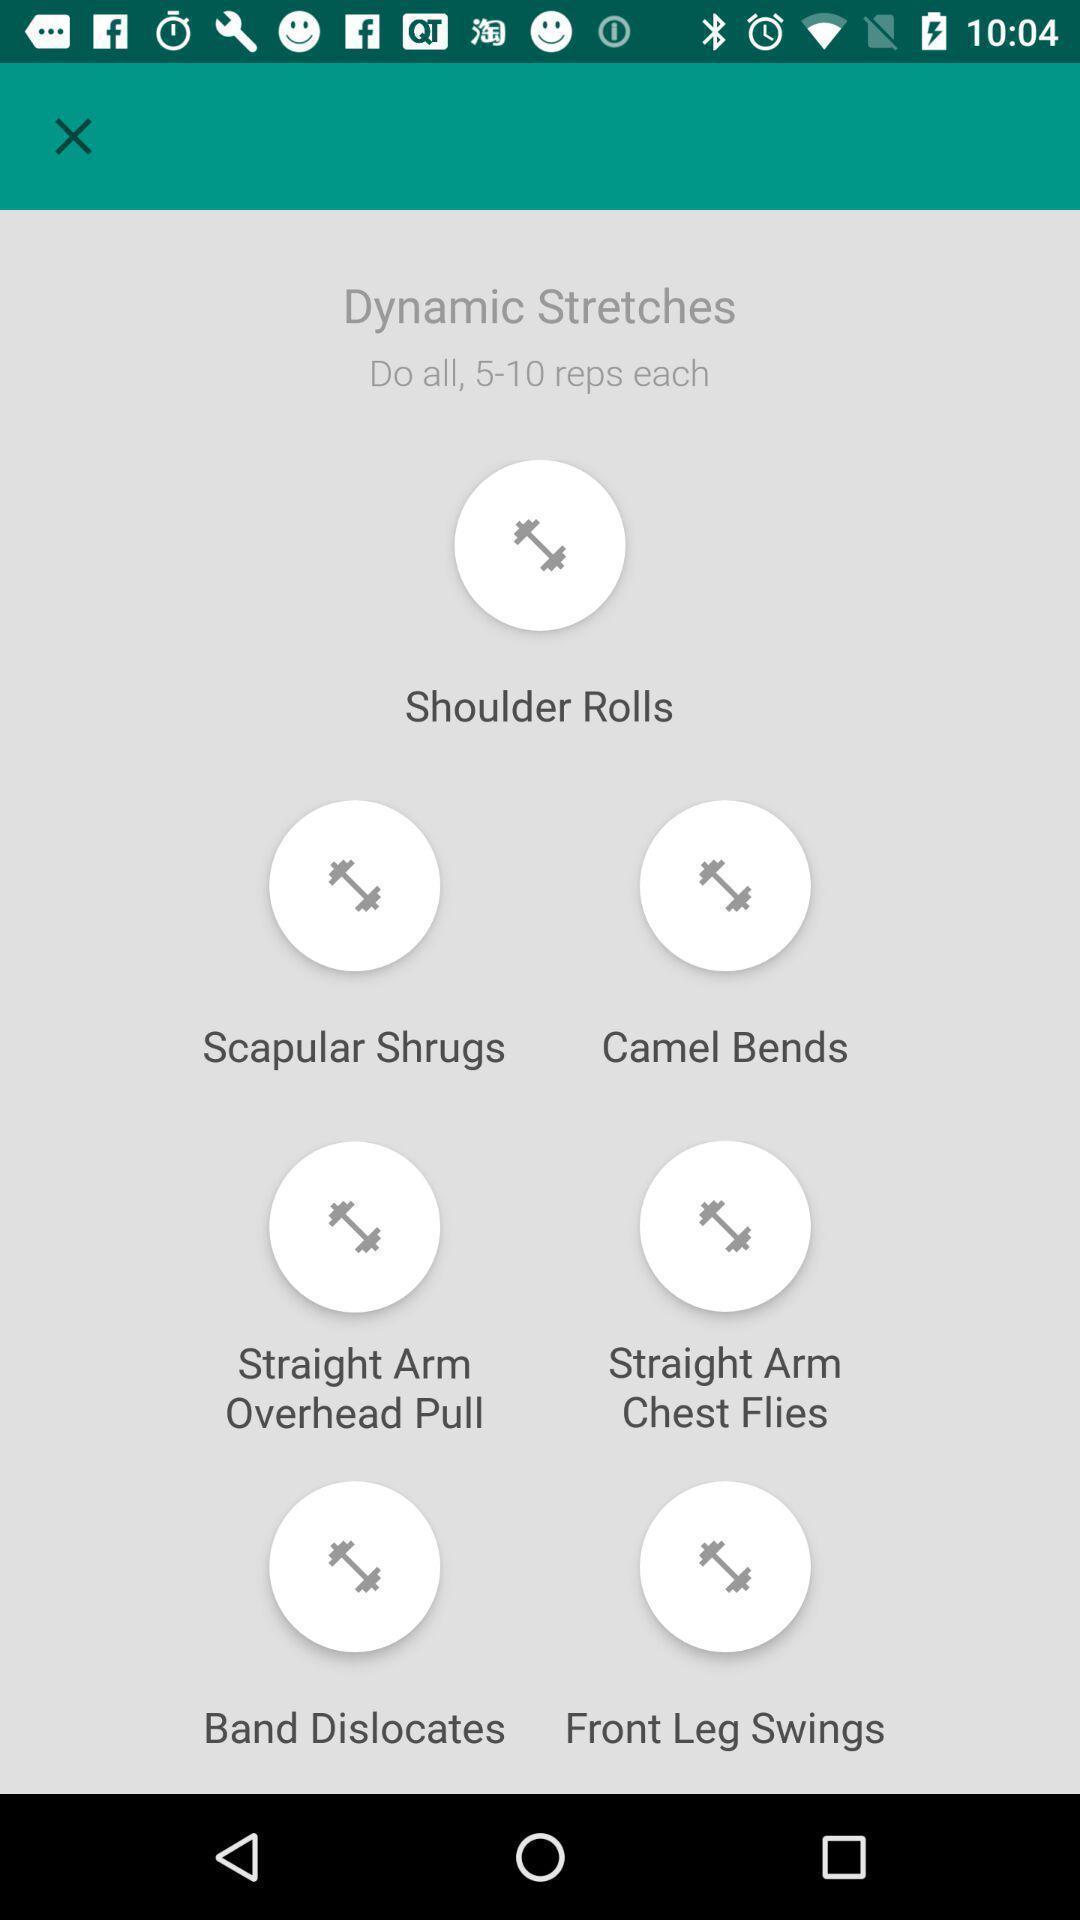What can you discern from this picture? Page displaying multiple workouts. 